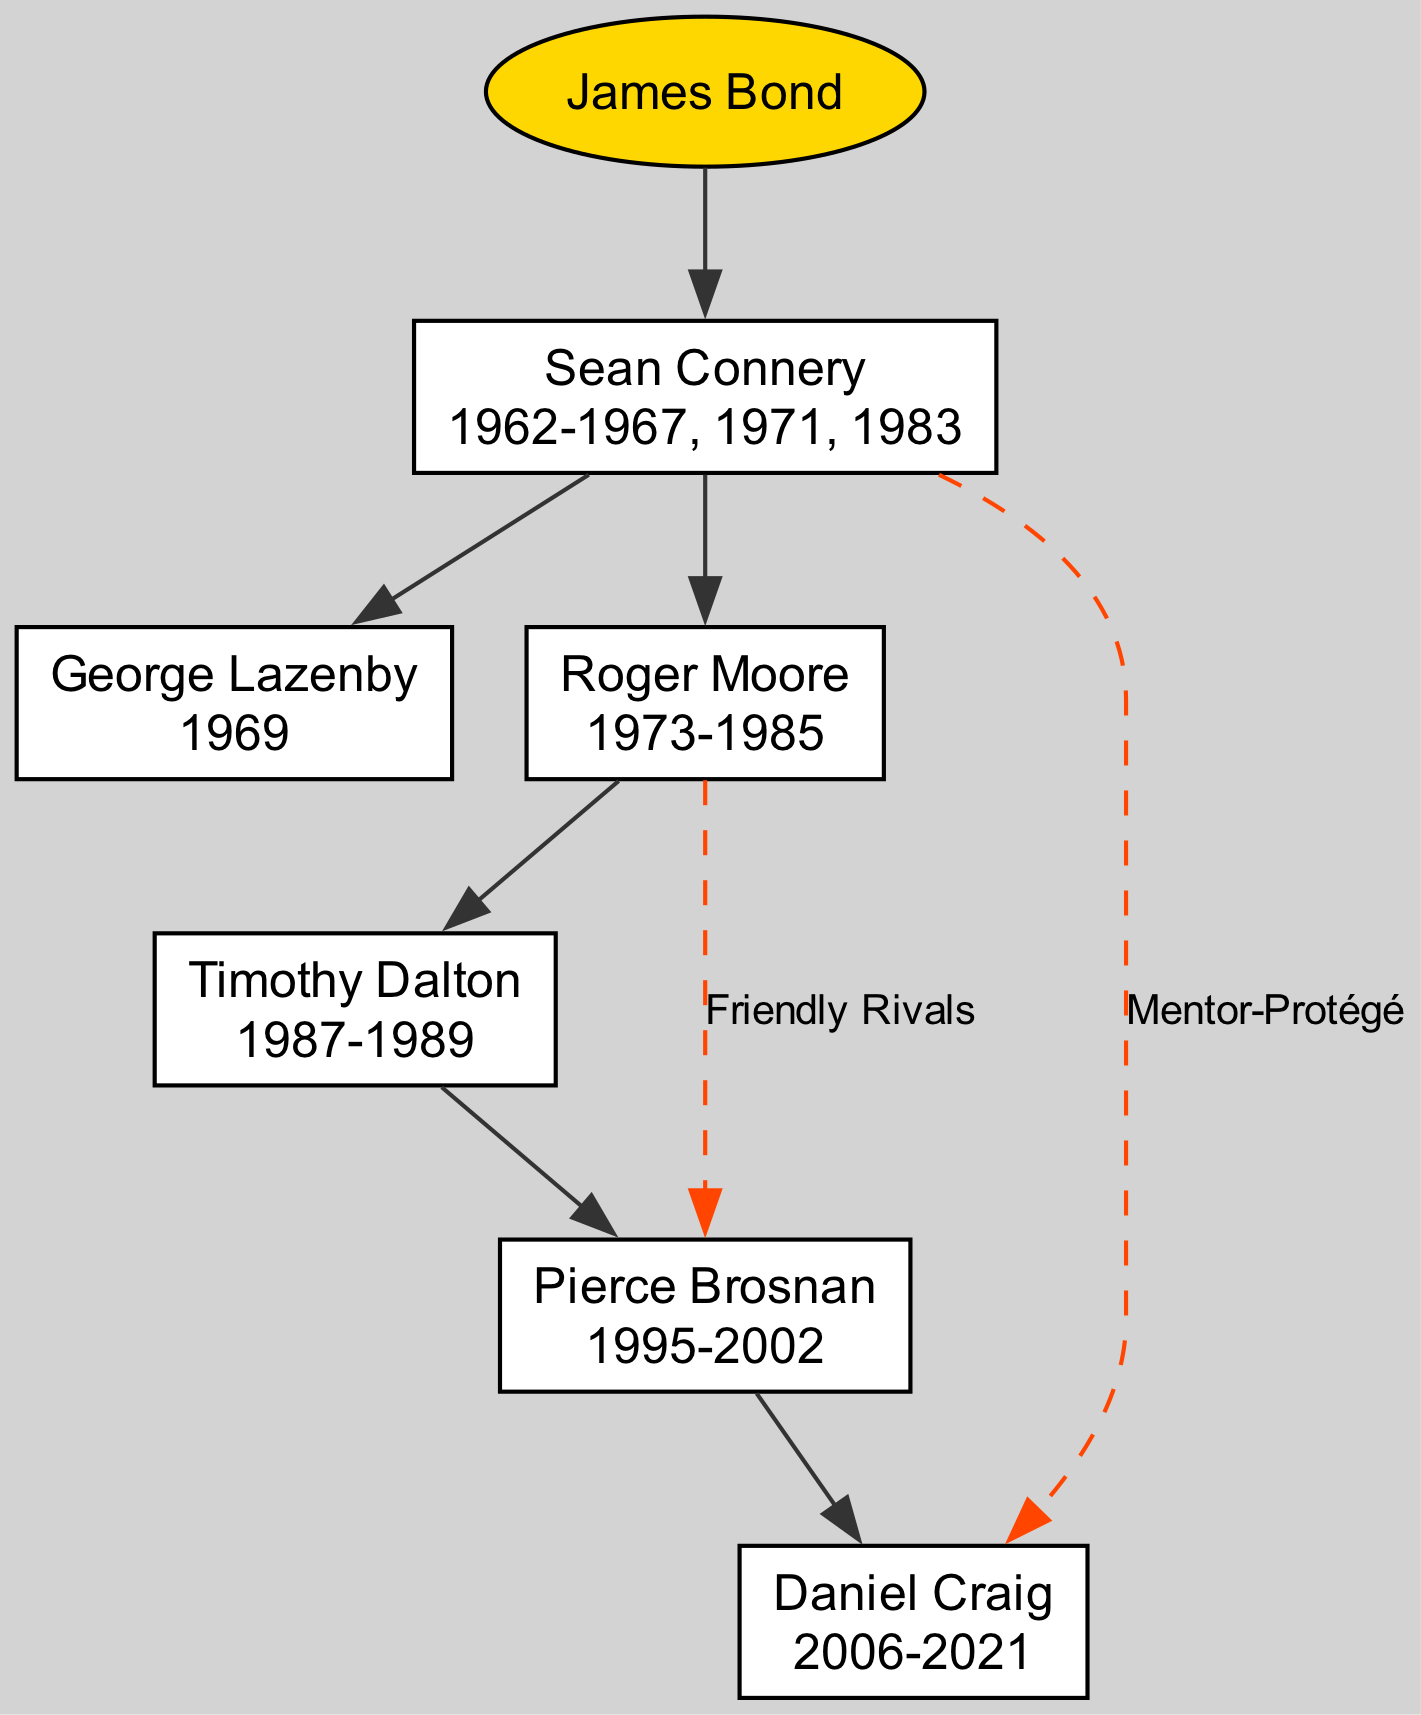What is the root of the family tree? The root of the family tree is identified as the main character who connects all other actors, which is explicitly stated in the diagram's data as "James Bond."
Answer: James Bond Who played James Bond in 1969? The children of the first generation node indicate the actors who portrayed James Bond. The node that represents the year 1969 lists "George Lazenby" as the actor during that year.
Answer: George Lazenby How many actors have played James Bond after Sean Connery? By examining the descendants of Sean Connery’s node, I see that there are five actors listed (George Lazenby, Roger Moore, Timothy Dalton, Pierce Brosnan, Daniel Craig). Counting these gives five total actors.
Answer: 5 What relationship is indicated between Roger Moore and Pierce Brosnan? The connection between Roger Moore and Pierce Brosnan is illustrated in the diagram, and the label on the edge indicates their relationship as "Friendly Rivals." This means there is a direct connection made in the diagram between these two characters.
Answer: Friendly Rivals Who is the mentor of Daniel Craig in the family tree? The diagram shows a specific connection from Sean Connery to Daniel Craig, labeled "Mentor-Protégé." This indicates that Sean Connery acted as a mentor to Daniel Craig in terms of their shared character.
Answer: Sean Connery In which years did Roger Moore portray James Bond? Looking closely at Roger Moore's node, the years he portrayed James Bond are provided directly in his label, stating "1973-1985." This information is clearly detailed within the diagram itself.
Answer: 1973-1985 What is the total number of generations represented in the family tree? By examining the hierarchical structure of the diagram, I can see that there is one generation beneath the root (Sean Connery) and all of his descendants represent the next level. This indicates there are two generations in total (root plus one).
Answer: 2 What is the connection type between Sean Connery and Daniel Craig? The diagram defines the link between Sean Connery and Daniel Craig through a dashed edge labeled "Mentor-Protégé," indicating a specific type of relationship that is described directly on the diagram.
Answer: Mentor-Protégé Which actor had the longest tenure portraying James Bond? By evaluating the years associated with each actor's node, Sean Connery spans the most years (1962-1967, 1971, 1983), making him the longest-tenured actor in the tree.
Answer: Sean Connery 